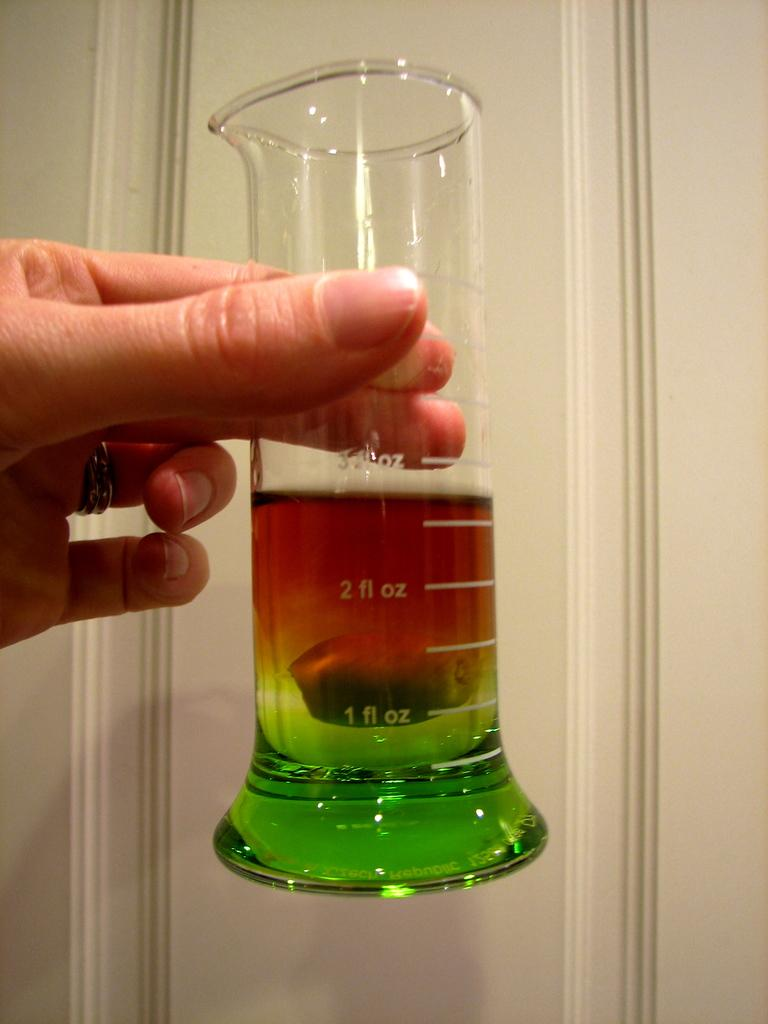Provide a one-sentence caption for the provided image. The liquid measures 2.75 fl oz in the container. 